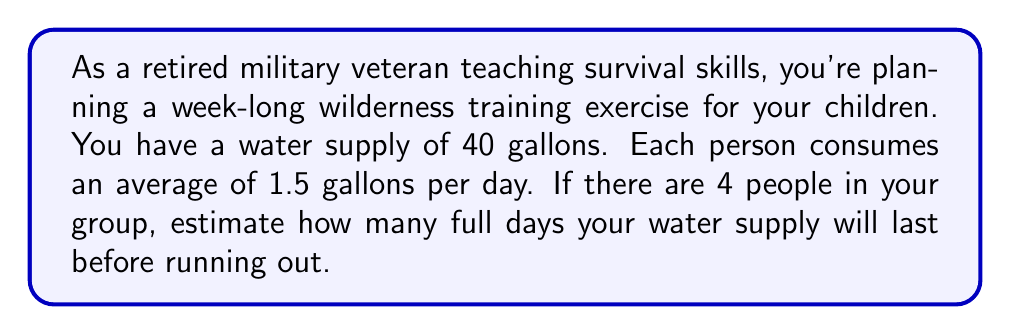Help me with this question. To solve this problem, we need to follow these steps:

1. Calculate the total daily water consumption for the group:
   $$ \text{Daily consumption} = \text{Number of people} \times \text{Consumption per person per day} $$
   $$ \text{Daily consumption} = 4 \times 1.5 \text{ gallons} = 6 \text{ gallons per day} $$

2. Calculate how long the water supply will last:
   $$ \text{Days of supply} = \frac{\text{Total water supply}}{\text{Daily consumption}} $$
   $$ \text{Days of supply} = \frac{40 \text{ gallons}}{6 \text{ gallons per day}} = \frac{20}{3} \text{ days} $$

3. Convert the fraction to a decimal:
   $$ \frac{20}{3} \approx 6.67 \text{ days} $$

4. Since we're asked for the number of full days, we need to round down to the nearest whole number.

Therefore, the water supply will last for 6 full days before running out on the 7th day.
Answer: 6 days 